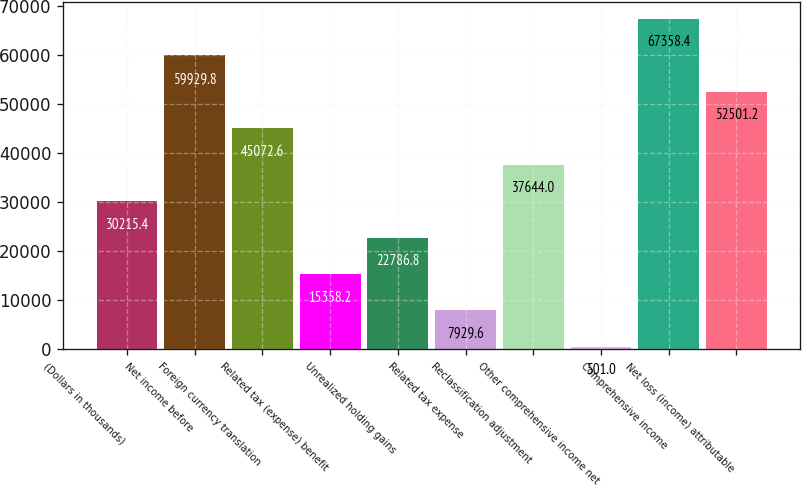<chart> <loc_0><loc_0><loc_500><loc_500><bar_chart><fcel>(Dollars in thousands)<fcel>Net income before<fcel>Foreign currency translation<fcel>Related tax (expense) benefit<fcel>Unrealized holding gains<fcel>Related tax expense<fcel>Reclassification adjustment<fcel>Other comprehensive income net<fcel>Comprehensive income<fcel>Net loss (income) attributable<nl><fcel>30215.4<fcel>59929.8<fcel>45072.6<fcel>15358.2<fcel>22786.8<fcel>7929.6<fcel>37644<fcel>501<fcel>67358.4<fcel>52501.2<nl></chart> 